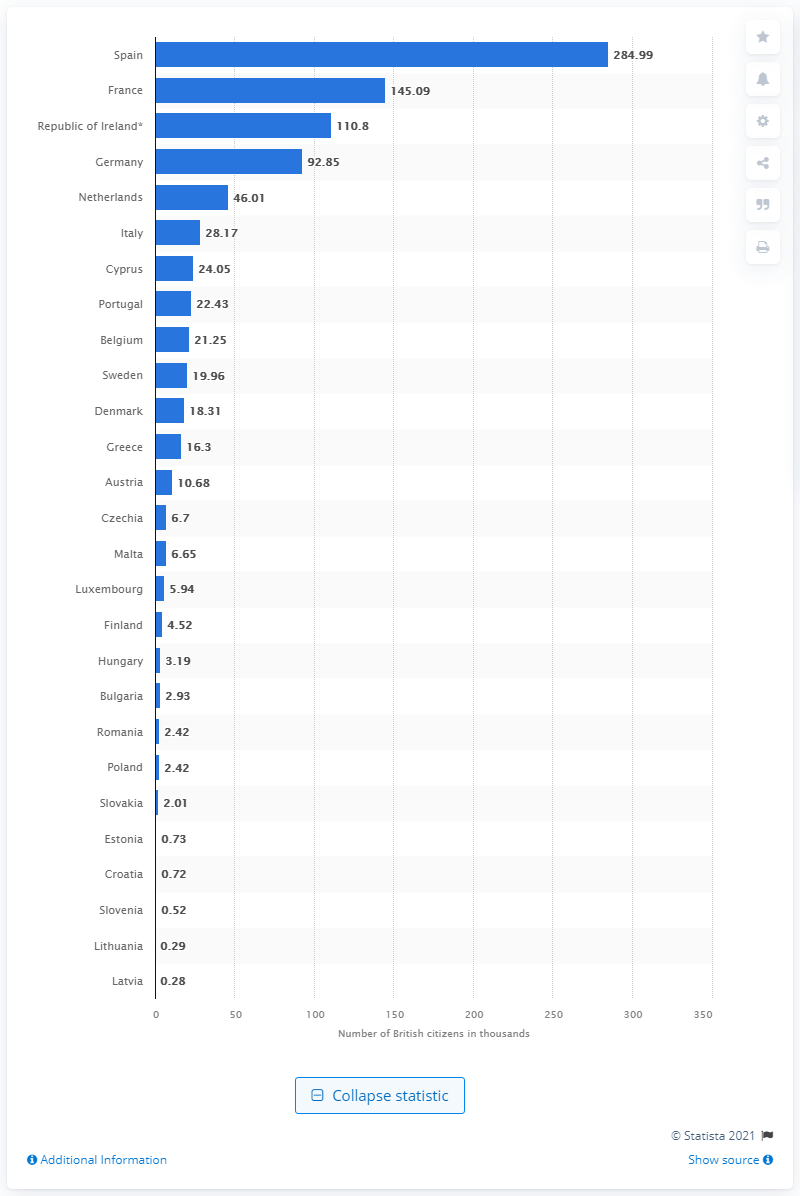Specify some key components in this picture. In 2018, 283 British citizens were living in Latvia, which is a member state of the European Union. 